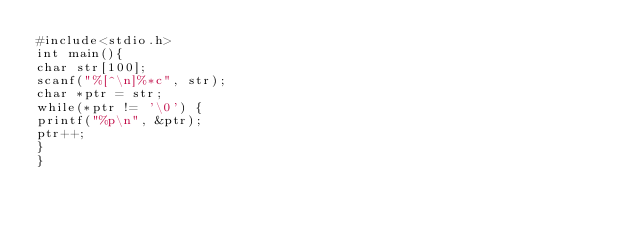<code> <loc_0><loc_0><loc_500><loc_500><_C_>#include<stdio.h>
int main(){
char str[100];
scanf("%[^\n]%*c", str);
char *ptr = str;
while(*ptr != '\0') {
printf("%p\n", &ptr);
ptr++;
}
}
</code> 